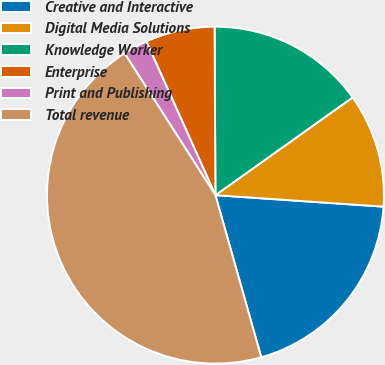<chart> <loc_0><loc_0><loc_500><loc_500><pie_chart><fcel>Creative and Interactive<fcel>Digital Media Solutions<fcel>Knowledge Worker<fcel>Enterprise<fcel>Print and Publishing<fcel>Total revenue<nl><fcel>19.53%<fcel>10.94%<fcel>15.23%<fcel>6.64%<fcel>2.35%<fcel>45.31%<nl></chart> 